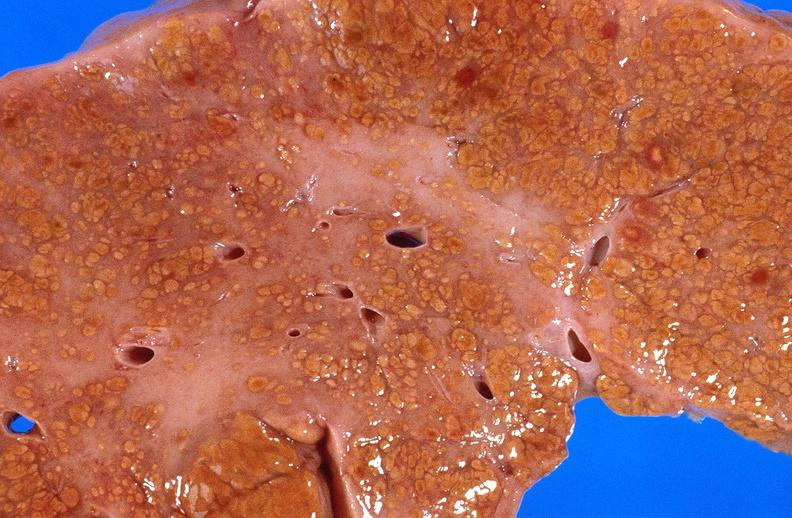what is present?
Answer the question using a single word or phrase. Liver 